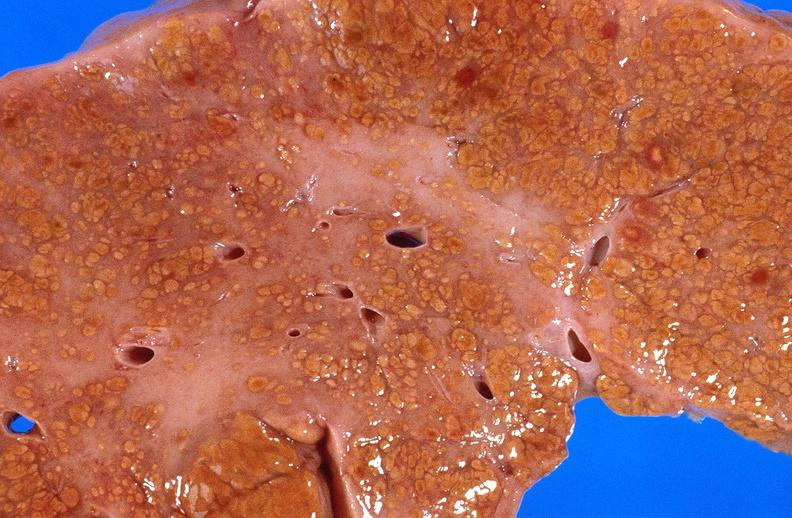what is present?
Answer the question using a single word or phrase. Liver 